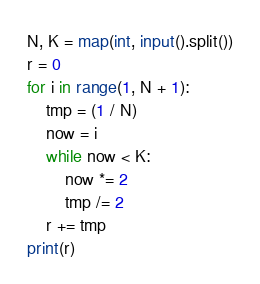<code> <loc_0><loc_0><loc_500><loc_500><_Python_>N, K = map(int, input().split())
r = 0
for i in range(1, N + 1):
    tmp = (1 / N)
    now = i
    while now < K:
        now *= 2
        tmp /= 2
    r += tmp
print(r)</code> 